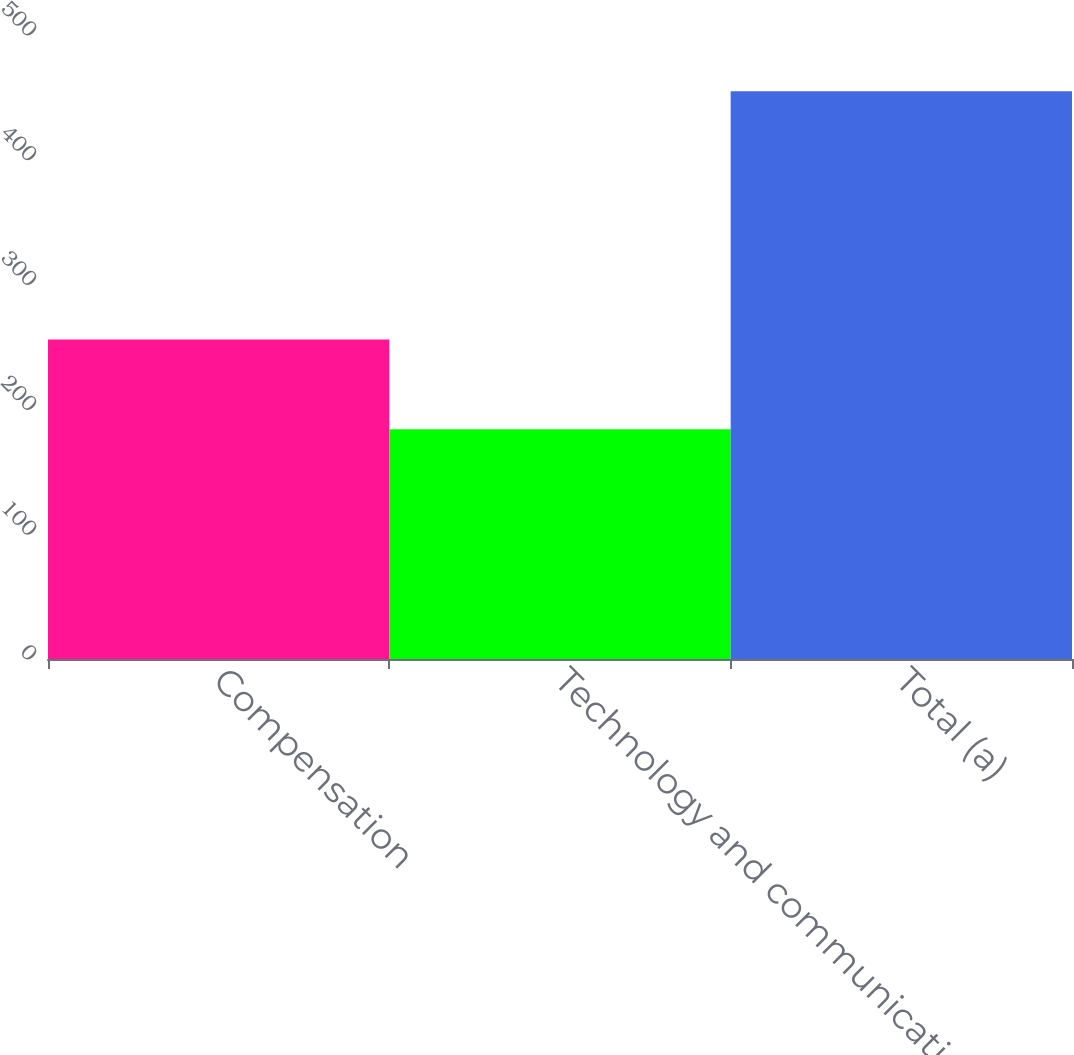Convert chart. <chart><loc_0><loc_0><loc_500><loc_500><bar_chart><fcel>Compensation<fcel>Technology and communications<fcel>Total (a)<nl><fcel>256<fcel>184<fcel>455<nl></chart> 